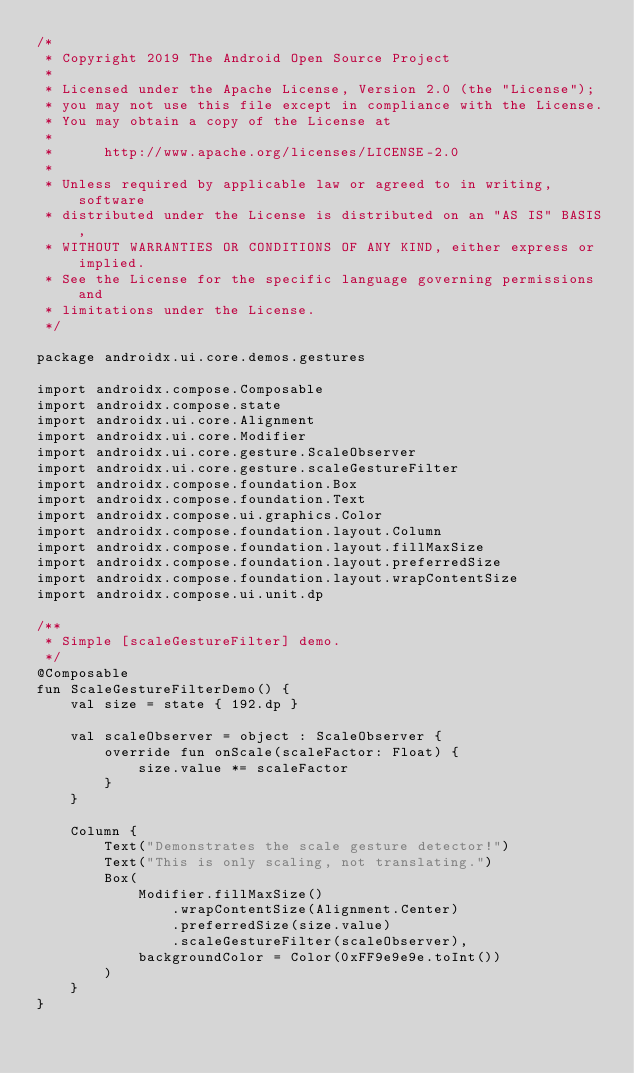Convert code to text. <code><loc_0><loc_0><loc_500><loc_500><_Kotlin_>/*
 * Copyright 2019 The Android Open Source Project
 *
 * Licensed under the Apache License, Version 2.0 (the "License");
 * you may not use this file except in compliance with the License.
 * You may obtain a copy of the License at
 *
 *      http://www.apache.org/licenses/LICENSE-2.0
 *
 * Unless required by applicable law or agreed to in writing, software
 * distributed under the License is distributed on an "AS IS" BASIS,
 * WITHOUT WARRANTIES OR CONDITIONS OF ANY KIND, either express or implied.
 * See the License for the specific language governing permissions and
 * limitations under the License.
 */

package androidx.ui.core.demos.gestures

import androidx.compose.Composable
import androidx.compose.state
import androidx.ui.core.Alignment
import androidx.ui.core.Modifier
import androidx.ui.core.gesture.ScaleObserver
import androidx.ui.core.gesture.scaleGestureFilter
import androidx.compose.foundation.Box
import androidx.compose.foundation.Text
import androidx.compose.ui.graphics.Color
import androidx.compose.foundation.layout.Column
import androidx.compose.foundation.layout.fillMaxSize
import androidx.compose.foundation.layout.preferredSize
import androidx.compose.foundation.layout.wrapContentSize
import androidx.compose.ui.unit.dp

/**
 * Simple [scaleGestureFilter] demo.
 */
@Composable
fun ScaleGestureFilterDemo() {
    val size = state { 192.dp }

    val scaleObserver = object : ScaleObserver {
        override fun onScale(scaleFactor: Float) {
            size.value *= scaleFactor
        }
    }

    Column {
        Text("Demonstrates the scale gesture detector!")
        Text("This is only scaling, not translating.")
        Box(
            Modifier.fillMaxSize()
                .wrapContentSize(Alignment.Center)
                .preferredSize(size.value)
                .scaleGestureFilter(scaleObserver),
            backgroundColor = Color(0xFF9e9e9e.toInt())
        )
    }
}
</code> 